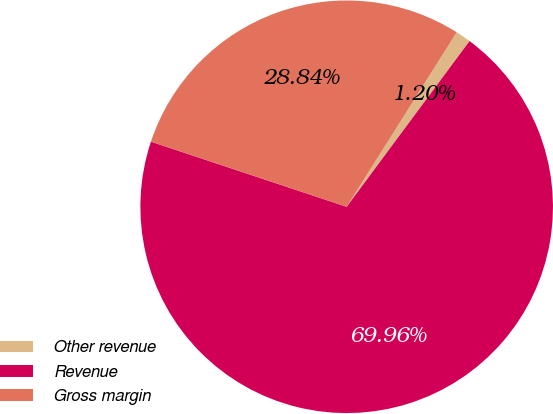Convert chart. <chart><loc_0><loc_0><loc_500><loc_500><pie_chart><fcel>Other revenue<fcel>Revenue<fcel>Gross margin<nl><fcel>1.2%<fcel>69.96%<fcel>28.84%<nl></chart> 